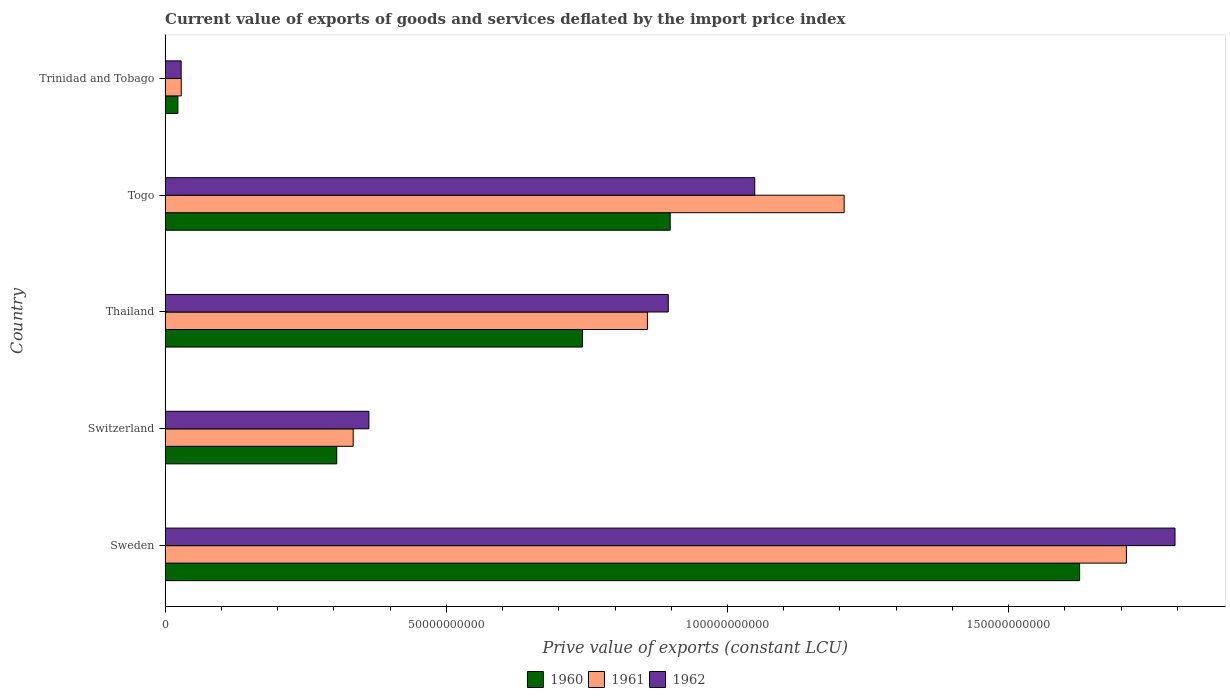Are the number of bars per tick equal to the number of legend labels?
Ensure brevity in your answer.  Yes. What is the label of the 2nd group of bars from the top?
Keep it short and to the point. Togo. What is the prive value of exports in 1960 in Sweden?
Provide a succinct answer. 1.63e+11. Across all countries, what is the maximum prive value of exports in 1960?
Ensure brevity in your answer.  1.63e+11. Across all countries, what is the minimum prive value of exports in 1962?
Offer a very short reply. 2.86e+09. In which country was the prive value of exports in 1962 minimum?
Offer a very short reply. Trinidad and Tobago. What is the total prive value of exports in 1961 in the graph?
Your response must be concise. 4.14e+11. What is the difference between the prive value of exports in 1962 in Sweden and that in Trinidad and Tobago?
Give a very brief answer. 1.77e+11. What is the difference between the prive value of exports in 1961 in Thailand and the prive value of exports in 1962 in Switzerland?
Offer a terse response. 4.95e+1. What is the average prive value of exports in 1961 per country?
Provide a short and direct response. 8.28e+1. What is the difference between the prive value of exports in 1961 and prive value of exports in 1962 in Togo?
Keep it short and to the point. 1.59e+1. What is the ratio of the prive value of exports in 1960 in Sweden to that in Togo?
Ensure brevity in your answer.  1.81. Is the prive value of exports in 1961 in Sweden less than that in Trinidad and Tobago?
Provide a succinct answer. No. Is the difference between the prive value of exports in 1961 in Switzerland and Togo greater than the difference between the prive value of exports in 1962 in Switzerland and Togo?
Your answer should be compact. No. What is the difference between the highest and the second highest prive value of exports in 1960?
Your answer should be compact. 7.28e+1. What is the difference between the highest and the lowest prive value of exports in 1960?
Keep it short and to the point. 1.60e+11. Is the sum of the prive value of exports in 1961 in Switzerland and Thailand greater than the maximum prive value of exports in 1962 across all countries?
Provide a succinct answer. No. Are all the bars in the graph horizontal?
Your answer should be very brief. Yes. What is the difference between two consecutive major ticks on the X-axis?
Make the answer very short. 5.00e+1. Where does the legend appear in the graph?
Ensure brevity in your answer.  Bottom center. How many legend labels are there?
Give a very brief answer. 3. How are the legend labels stacked?
Provide a short and direct response. Horizontal. What is the title of the graph?
Offer a very short reply. Current value of exports of goods and services deflated by the import price index. What is the label or title of the X-axis?
Make the answer very short. Prive value of exports (constant LCU). What is the Prive value of exports (constant LCU) of 1960 in Sweden?
Ensure brevity in your answer.  1.63e+11. What is the Prive value of exports (constant LCU) of 1961 in Sweden?
Make the answer very short. 1.71e+11. What is the Prive value of exports (constant LCU) in 1962 in Sweden?
Your answer should be very brief. 1.80e+11. What is the Prive value of exports (constant LCU) in 1960 in Switzerland?
Make the answer very short. 3.05e+1. What is the Prive value of exports (constant LCU) in 1961 in Switzerland?
Your answer should be compact. 3.34e+1. What is the Prive value of exports (constant LCU) in 1962 in Switzerland?
Offer a terse response. 3.62e+1. What is the Prive value of exports (constant LCU) of 1960 in Thailand?
Make the answer very short. 7.42e+1. What is the Prive value of exports (constant LCU) of 1961 in Thailand?
Keep it short and to the point. 8.58e+1. What is the Prive value of exports (constant LCU) of 1962 in Thailand?
Ensure brevity in your answer.  8.95e+1. What is the Prive value of exports (constant LCU) of 1960 in Togo?
Offer a very short reply. 8.98e+1. What is the Prive value of exports (constant LCU) in 1961 in Togo?
Ensure brevity in your answer.  1.21e+11. What is the Prive value of exports (constant LCU) in 1962 in Togo?
Your answer should be very brief. 1.05e+11. What is the Prive value of exports (constant LCU) in 1960 in Trinidad and Tobago?
Offer a terse response. 2.28e+09. What is the Prive value of exports (constant LCU) of 1961 in Trinidad and Tobago?
Make the answer very short. 2.87e+09. What is the Prive value of exports (constant LCU) of 1962 in Trinidad and Tobago?
Your answer should be very brief. 2.86e+09. Across all countries, what is the maximum Prive value of exports (constant LCU) in 1960?
Offer a very short reply. 1.63e+11. Across all countries, what is the maximum Prive value of exports (constant LCU) in 1961?
Your answer should be compact. 1.71e+11. Across all countries, what is the maximum Prive value of exports (constant LCU) in 1962?
Make the answer very short. 1.80e+11. Across all countries, what is the minimum Prive value of exports (constant LCU) in 1960?
Make the answer very short. 2.28e+09. Across all countries, what is the minimum Prive value of exports (constant LCU) in 1961?
Provide a succinct answer. 2.87e+09. Across all countries, what is the minimum Prive value of exports (constant LCU) of 1962?
Provide a short and direct response. 2.86e+09. What is the total Prive value of exports (constant LCU) in 1960 in the graph?
Your response must be concise. 3.59e+11. What is the total Prive value of exports (constant LCU) of 1961 in the graph?
Your response must be concise. 4.14e+11. What is the total Prive value of exports (constant LCU) in 1962 in the graph?
Offer a very short reply. 4.13e+11. What is the difference between the Prive value of exports (constant LCU) of 1960 in Sweden and that in Switzerland?
Give a very brief answer. 1.32e+11. What is the difference between the Prive value of exports (constant LCU) in 1961 in Sweden and that in Switzerland?
Offer a terse response. 1.37e+11. What is the difference between the Prive value of exports (constant LCU) in 1962 in Sweden and that in Switzerland?
Provide a short and direct response. 1.43e+11. What is the difference between the Prive value of exports (constant LCU) of 1960 in Sweden and that in Thailand?
Provide a short and direct response. 8.84e+1. What is the difference between the Prive value of exports (constant LCU) of 1961 in Sweden and that in Thailand?
Provide a short and direct response. 8.52e+1. What is the difference between the Prive value of exports (constant LCU) of 1962 in Sweden and that in Thailand?
Make the answer very short. 9.01e+1. What is the difference between the Prive value of exports (constant LCU) of 1960 in Sweden and that in Togo?
Ensure brevity in your answer.  7.28e+1. What is the difference between the Prive value of exports (constant LCU) in 1961 in Sweden and that in Togo?
Keep it short and to the point. 5.02e+1. What is the difference between the Prive value of exports (constant LCU) of 1962 in Sweden and that in Togo?
Your response must be concise. 7.47e+1. What is the difference between the Prive value of exports (constant LCU) in 1960 in Sweden and that in Trinidad and Tobago?
Give a very brief answer. 1.60e+11. What is the difference between the Prive value of exports (constant LCU) in 1961 in Sweden and that in Trinidad and Tobago?
Your answer should be very brief. 1.68e+11. What is the difference between the Prive value of exports (constant LCU) of 1962 in Sweden and that in Trinidad and Tobago?
Provide a succinct answer. 1.77e+11. What is the difference between the Prive value of exports (constant LCU) of 1960 in Switzerland and that in Thailand?
Ensure brevity in your answer.  -4.37e+1. What is the difference between the Prive value of exports (constant LCU) in 1961 in Switzerland and that in Thailand?
Provide a succinct answer. -5.23e+1. What is the difference between the Prive value of exports (constant LCU) of 1962 in Switzerland and that in Thailand?
Offer a terse response. -5.32e+1. What is the difference between the Prive value of exports (constant LCU) of 1960 in Switzerland and that in Togo?
Your response must be concise. -5.93e+1. What is the difference between the Prive value of exports (constant LCU) in 1961 in Switzerland and that in Togo?
Offer a very short reply. -8.73e+1. What is the difference between the Prive value of exports (constant LCU) in 1962 in Switzerland and that in Togo?
Ensure brevity in your answer.  -6.86e+1. What is the difference between the Prive value of exports (constant LCU) of 1960 in Switzerland and that in Trinidad and Tobago?
Your response must be concise. 2.82e+1. What is the difference between the Prive value of exports (constant LCU) of 1961 in Switzerland and that in Trinidad and Tobago?
Provide a succinct answer. 3.06e+1. What is the difference between the Prive value of exports (constant LCU) of 1962 in Switzerland and that in Trinidad and Tobago?
Offer a very short reply. 3.34e+1. What is the difference between the Prive value of exports (constant LCU) in 1960 in Thailand and that in Togo?
Provide a short and direct response. -1.56e+1. What is the difference between the Prive value of exports (constant LCU) in 1961 in Thailand and that in Togo?
Your response must be concise. -3.50e+1. What is the difference between the Prive value of exports (constant LCU) of 1962 in Thailand and that in Togo?
Give a very brief answer. -1.54e+1. What is the difference between the Prive value of exports (constant LCU) of 1960 in Thailand and that in Trinidad and Tobago?
Offer a terse response. 7.20e+1. What is the difference between the Prive value of exports (constant LCU) in 1961 in Thailand and that in Trinidad and Tobago?
Provide a succinct answer. 8.29e+1. What is the difference between the Prive value of exports (constant LCU) in 1962 in Thailand and that in Trinidad and Tobago?
Give a very brief answer. 8.66e+1. What is the difference between the Prive value of exports (constant LCU) of 1960 in Togo and that in Trinidad and Tobago?
Provide a short and direct response. 8.75e+1. What is the difference between the Prive value of exports (constant LCU) of 1961 in Togo and that in Trinidad and Tobago?
Provide a short and direct response. 1.18e+11. What is the difference between the Prive value of exports (constant LCU) in 1962 in Togo and that in Trinidad and Tobago?
Provide a short and direct response. 1.02e+11. What is the difference between the Prive value of exports (constant LCU) of 1960 in Sweden and the Prive value of exports (constant LCU) of 1961 in Switzerland?
Your answer should be compact. 1.29e+11. What is the difference between the Prive value of exports (constant LCU) in 1960 in Sweden and the Prive value of exports (constant LCU) in 1962 in Switzerland?
Provide a short and direct response. 1.26e+11. What is the difference between the Prive value of exports (constant LCU) of 1961 in Sweden and the Prive value of exports (constant LCU) of 1962 in Switzerland?
Your answer should be compact. 1.35e+11. What is the difference between the Prive value of exports (constant LCU) in 1960 in Sweden and the Prive value of exports (constant LCU) in 1961 in Thailand?
Your answer should be compact. 7.69e+1. What is the difference between the Prive value of exports (constant LCU) in 1960 in Sweden and the Prive value of exports (constant LCU) in 1962 in Thailand?
Provide a succinct answer. 7.31e+1. What is the difference between the Prive value of exports (constant LCU) of 1961 in Sweden and the Prive value of exports (constant LCU) of 1962 in Thailand?
Ensure brevity in your answer.  8.15e+1. What is the difference between the Prive value of exports (constant LCU) in 1960 in Sweden and the Prive value of exports (constant LCU) in 1961 in Togo?
Your answer should be compact. 4.19e+1. What is the difference between the Prive value of exports (constant LCU) of 1960 in Sweden and the Prive value of exports (constant LCU) of 1962 in Togo?
Keep it short and to the point. 5.78e+1. What is the difference between the Prive value of exports (constant LCU) of 1961 in Sweden and the Prive value of exports (constant LCU) of 1962 in Togo?
Give a very brief answer. 6.61e+1. What is the difference between the Prive value of exports (constant LCU) of 1960 in Sweden and the Prive value of exports (constant LCU) of 1961 in Trinidad and Tobago?
Offer a very short reply. 1.60e+11. What is the difference between the Prive value of exports (constant LCU) in 1960 in Sweden and the Prive value of exports (constant LCU) in 1962 in Trinidad and Tobago?
Offer a terse response. 1.60e+11. What is the difference between the Prive value of exports (constant LCU) in 1961 in Sweden and the Prive value of exports (constant LCU) in 1962 in Trinidad and Tobago?
Provide a short and direct response. 1.68e+11. What is the difference between the Prive value of exports (constant LCU) of 1960 in Switzerland and the Prive value of exports (constant LCU) of 1961 in Thailand?
Offer a terse response. -5.52e+1. What is the difference between the Prive value of exports (constant LCU) in 1960 in Switzerland and the Prive value of exports (constant LCU) in 1962 in Thailand?
Provide a short and direct response. -5.89e+1. What is the difference between the Prive value of exports (constant LCU) in 1961 in Switzerland and the Prive value of exports (constant LCU) in 1962 in Thailand?
Your response must be concise. -5.60e+1. What is the difference between the Prive value of exports (constant LCU) in 1960 in Switzerland and the Prive value of exports (constant LCU) in 1961 in Togo?
Ensure brevity in your answer.  -9.02e+1. What is the difference between the Prive value of exports (constant LCU) of 1960 in Switzerland and the Prive value of exports (constant LCU) of 1962 in Togo?
Your answer should be very brief. -7.43e+1. What is the difference between the Prive value of exports (constant LCU) of 1961 in Switzerland and the Prive value of exports (constant LCU) of 1962 in Togo?
Give a very brief answer. -7.14e+1. What is the difference between the Prive value of exports (constant LCU) of 1960 in Switzerland and the Prive value of exports (constant LCU) of 1961 in Trinidad and Tobago?
Ensure brevity in your answer.  2.76e+1. What is the difference between the Prive value of exports (constant LCU) in 1960 in Switzerland and the Prive value of exports (constant LCU) in 1962 in Trinidad and Tobago?
Give a very brief answer. 2.77e+1. What is the difference between the Prive value of exports (constant LCU) of 1961 in Switzerland and the Prive value of exports (constant LCU) of 1962 in Trinidad and Tobago?
Make the answer very short. 3.06e+1. What is the difference between the Prive value of exports (constant LCU) in 1960 in Thailand and the Prive value of exports (constant LCU) in 1961 in Togo?
Your answer should be very brief. -4.65e+1. What is the difference between the Prive value of exports (constant LCU) of 1960 in Thailand and the Prive value of exports (constant LCU) of 1962 in Togo?
Keep it short and to the point. -3.06e+1. What is the difference between the Prive value of exports (constant LCU) in 1961 in Thailand and the Prive value of exports (constant LCU) in 1962 in Togo?
Give a very brief answer. -1.91e+1. What is the difference between the Prive value of exports (constant LCU) in 1960 in Thailand and the Prive value of exports (constant LCU) in 1961 in Trinidad and Tobago?
Your response must be concise. 7.14e+1. What is the difference between the Prive value of exports (constant LCU) in 1960 in Thailand and the Prive value of exports (constant LCU) in 1962 in Trinidad and Tobago?
Give a very brief answer. 7.14e+1. What is the difference between the Prive value of exports (constant LCU) of 1961 in Thailand and the Prive value of exports (constant LCU) of 1962 in Trinidad and Tobago?
Offer a terse response. 8.29e+1. What is the difference between the Prive value of exports (constant LCU) in 1960 in Togo and the Prive value of exports (constant LCU) in 1961 in Trinidad and Tobago?
Provide a succinct answer. 8.69e+1. What is the difference between the Prive value of exports (constant LCU) of 1960 in Togo and the Prive value of exports (constant LCU) of 1962 in Trinidad and Tobago?
Your answer should be compact. 8.70e+1. What is the difference between the Prive value of exports (constant LCU) of 1961 in Togo and the Prive value of exports (constant LCU) of 1962 in Trinidad and Tobago?
Your response must be concise. 1.18e+11. What is the average Prive value of exports (constant LCU) in 1960 per country?
Your answer should be compact. 7.19e+1. What is the average Prive value of exports (constant LCU) of 1961 per country?
Provide a short and direct response. 8.28e+1. What is the average Prive value of exports (constant LCU) in 1962 per country?
Keep it short and to the point. 8.26e+1. What is the difference between the Prive value of exports (constant LCU) in 1960 and Prive value of exports (constant LCU) in 1961 in Sweden?
Make the answer very short. -8.32e+09. What is the difference between the Prive value of exports (constant LCU) of 1960 and Prive value of exports (constant LCU) of 1962 in Sweden?
Ensure brevity in your answer.  -1.70e+1. What is the difference between the Prive value of exports (constant LCU) in 1961 and Prive value of exports (constant LCU) in 1962 in Sweden?
Make the answer very short. -8.64e+09. What is the difference between the Prive value of exports (constant LCU) in 1960 and Prive value of exports (constant LCU) in 1961 in Switzerland?
Offer a terse response. -2.93e+09. What is the difference between the Prive value of exports (constant LCU) of 1960 and Prive value of exports (constant LCU) of 1962 in Switzerland?
Provide a short and direct response. -5.72e+09. What is the difference between the Prive value of exports (constant LCU) in 1961 and Prive value of exports (constant LCU) in 1962 in Switzerland?
Offer a very short reply. -2.79e+09. What is the difference between the Prive value of exports (constant LCU) of 1960 and Prive value of exports (constant LCU) of 1961 in Thailand?
Offer a very short reply. -1.15e+1. What is the difference between the Prive value of exports (constant LCU) in 1960 and Prive value of exports (constant LCU) in 1962 in Thailand?
Offer a very short reply. -1.52e+1. What is the difference between the Prive value of exports (constant LCU) in 1961 and Prive value of exports (constant LCU) in 1962 in Thailand?
Your answer should be very brief. -3.71e+09. What is the difference between the Prive value of exports (constant LCU) in 1960 and Prive value of exports (constant LCU) in 1961 in Togo?
Give a very brief answer. -3.09e+1. What is the difference between the Prive value of exports (constant LCU) of 1960 and Prive value of exports (constant LCU) of 1962 in Togo?
Offer a very short reply. -1.50e+1. What is the difference between the Prive value of exports (constant LCU) of 1961 and Prive value of exports (constant LCU) of 1962 in Togo?
Offer a terse response. 1.59e+1. What is the difference between the Prive value of exports (constant LCU) of 1960 and Prive value of exports (constant LCU) of 1961 in Trinidad and Tobago?
Offer a terse response. -5.92e+08. What is the difference between the Prive value of exports (constant LCU) in 1960 and Prive value of exports (constant LCU) in 1962 in Trinidad and Tobago?
Keep it short and to the point. -5.79e+08. What is the difference between the Prive value of exports (constant LCU) of 1961 and Prive value of exports (constant LCU) of 1962 in Trinidad and Tobago?
Provide a short and direct response. 1.28e+07. What is the ratio of the Prive value of exports (constant LCU) in 1960 in Sweden to that in Switzerland?
Give a very brief answer. 5.33. What is the ratio of the Prive value of exports (constant LCU) of 1961 in Sweden to that in Switzerland?
Ensure brevity in your answer.  5.11. What is the ratio of the Prive value of exports (constant LCU) of 1962 in Sweden to that in Switzerland?
Keep it short and to the point. 4.96. What is the ratio of the Prive value of exports (constant LCU) in 1960 in Sweden to that in Thailand?
Provide a short and direct response. 2.19. What is the ratio of the Prive value of exports (constant LCU) of 1961 in Sweden to that in Thailand?
Give a very brief answer. 1.99. What is the ratio of the Prive value of exports (constant LCU) of 1962 in Sweden to that in Thailand?
Keep it short and to the point. 2.01. What is the ratio of the Prive value of exports (constant LCU) of 1960 in Sweden to that in Togo?
Give a very brief answer. 1.81. What is the ratio of the Prive value of exports (constant LCU) of 1961 in Sweden to that in Togo?
Provide a short and direct response. 1.42. What is the ratio of the Prive value of exports (constant LCU) of 1962 in Sweden to that in Togo?
Provide a succinct answer. 1.71. What is the ratio of the Prive value of exports (constant LCU) in 1960 in Sweden to that in Trinidad and Tobago?
Offer a very short reply. 71.39. What is the ratio of the Prive value of exports (constant LCU) in 1961 in Sweden to that in Trinidad and Tobago?
Keep it short and to the point. 59.57. What is the ratio of the Prive value of exports (constant LCU) in 1962 in Sweden to that in Trinidad and Tobago?
Make the answer very short. 62.86. What is the ratio of the Prive value of exports (constant LCU) in 1960 in Switzerland to that in Thailand?
Provide a succinct answer. 0.41. What is the ratio of the Prive value of exports (constant LCU) of 1961 in Switzerland to that in Thailand?
Provide a short and direct response. 0.39. What is the ratio of the Prive value of exports (constant LCU) of 1962 in Switzerland to that in Thailand?
Keep it short and to the point. 0.41. What is the ratio of the Prive value of exports (constant LCU) of 1960 in Switzerland to that in Togo?
Provide a short and direct response. 0.34. What is the ratio of the Prive value of exports (constant LCU) in 1961 in Switzerland to that in Togo?
Make the answer very short. 0.28. What is the ratio of the Prive value of exports (constant LCU) in 1962 in Switzerland to that in Togo?
Give a very brief answer. 0.35. What is the ratio of the Prive value of exports (constant LCU) in 1960 in Switzerland to that in Trinidad and Tobago?
Your answer should be very brief. 13.4. What is the ratio of the Prive value of exports (constant LCU) of 1961 in Switzerland to that in Trinidad and Tobago?
Provide a succinct answer. 11.66. What is the ratio of the Prive value of exports (constant LCU) in 1962 in Switzerland to that in Trinidad and Tobago?
Offer a terse response. 12.69. What is the ratio of the Prive value of exports (constant LCU) in 1960 in Thailand to that in Togo?
Give a very brief answer. 0.83. What is the ratio of the Prive value of exports (constant LCU) of 1961 in Thailand to that in Togo?
Give a very brief answer. 0.71. What is the ratio of the Prive value of exports (constant LCU) of 1962 in Thailand to that in Togo?
Give a very brief answer. 0.85. What is the ratio of the Prive value of exports (constant LCU) in 1960 in Thailand to that in Trinidad and Tobago?
Provide a short and direct response. 32.59. What is the ratio of the Prive value of exports (constant LCU) in 1961 in Thailand to that in Trinidad and Tobago?
Provide a short and direct response. 29.89. What is the ratio of the Prive value of exports (constant LCU) of 1962 in Thailand to that in Trinidad and Tobago?
Give a very brief answer. 31.32. What is the ratio of the Prive value of exports (constant LCU) of 1960 in Togo to that in Trinidad and Tobago?
Provide a succinct answer. 39.43. What is the ratio of the Prive value of exports (constant LCU) in 1961 in Togo to that in Trinidad and Tobago?
Your response must be concise. 42.08. What is the ratio of the Prive value of exports (constant LCU) in 1962 in Togo to that in Trinidad and Tobago?
Your answer should be very brief. 36.71. What is the difference between the highest and the second highest Prive value of exports (constant LCU) in 1960?
Your answer should be very brief. 7.28e+1. What is the difference between the highest and the second highest Prive value of exports (constant LCU) in 1961?
Make the answer very short. 5.02e+1. What is the difference between the highest and the second highest Prive value of exports (constant LCU) of 1962?
Your answer should be compact. 7.47e+1. What is the difference between the highest and the lowest Prive value of exports (constant LCU) of 1960?
Provide a short and direct response. 1.60e+11. What is the difference between the highest and the lowest Prive value of exports (constant LCU) in 1961?
Your answer should be compact. 1.68e+11. What is the difference between the highest and the lowest Prive value of exports (constant LCU) of 1962?
Provide a succinct answer. 1.77e+11. 